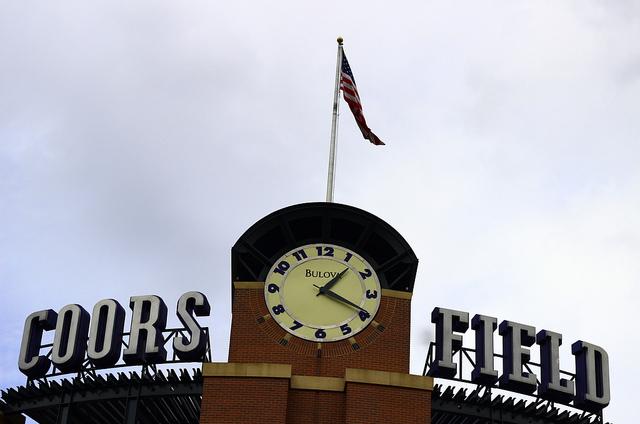What time is it?
Give a very brief answer. 1:20. Is there a flag above the clock?
Keep it brief. Yes. What field is this?
Give a very brief answer. Coors field. 